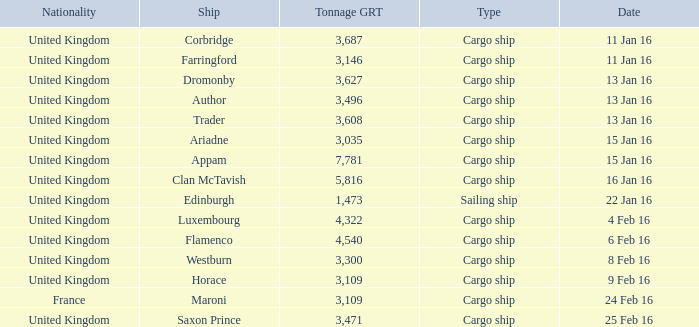What is the total tonnage grt of the cargo ship(s) sunk or captured on 4 feb 16? 1.0. 